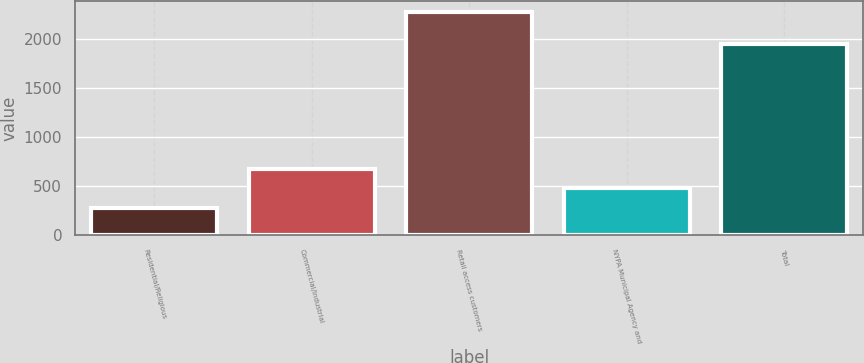<chart> <loc_0><loc_0><loc_500><loc_500><bar_chart><fcel>Residential/Religious<fcel>Commercial/Industrial<fcel>Retail access customers<fcel>NYPA Municipal Agency and<fcel>Total<nl><fcel>278<fcel>677.6<fcel>2276<fcel>477.8<fcel>1953<nl></chart> 